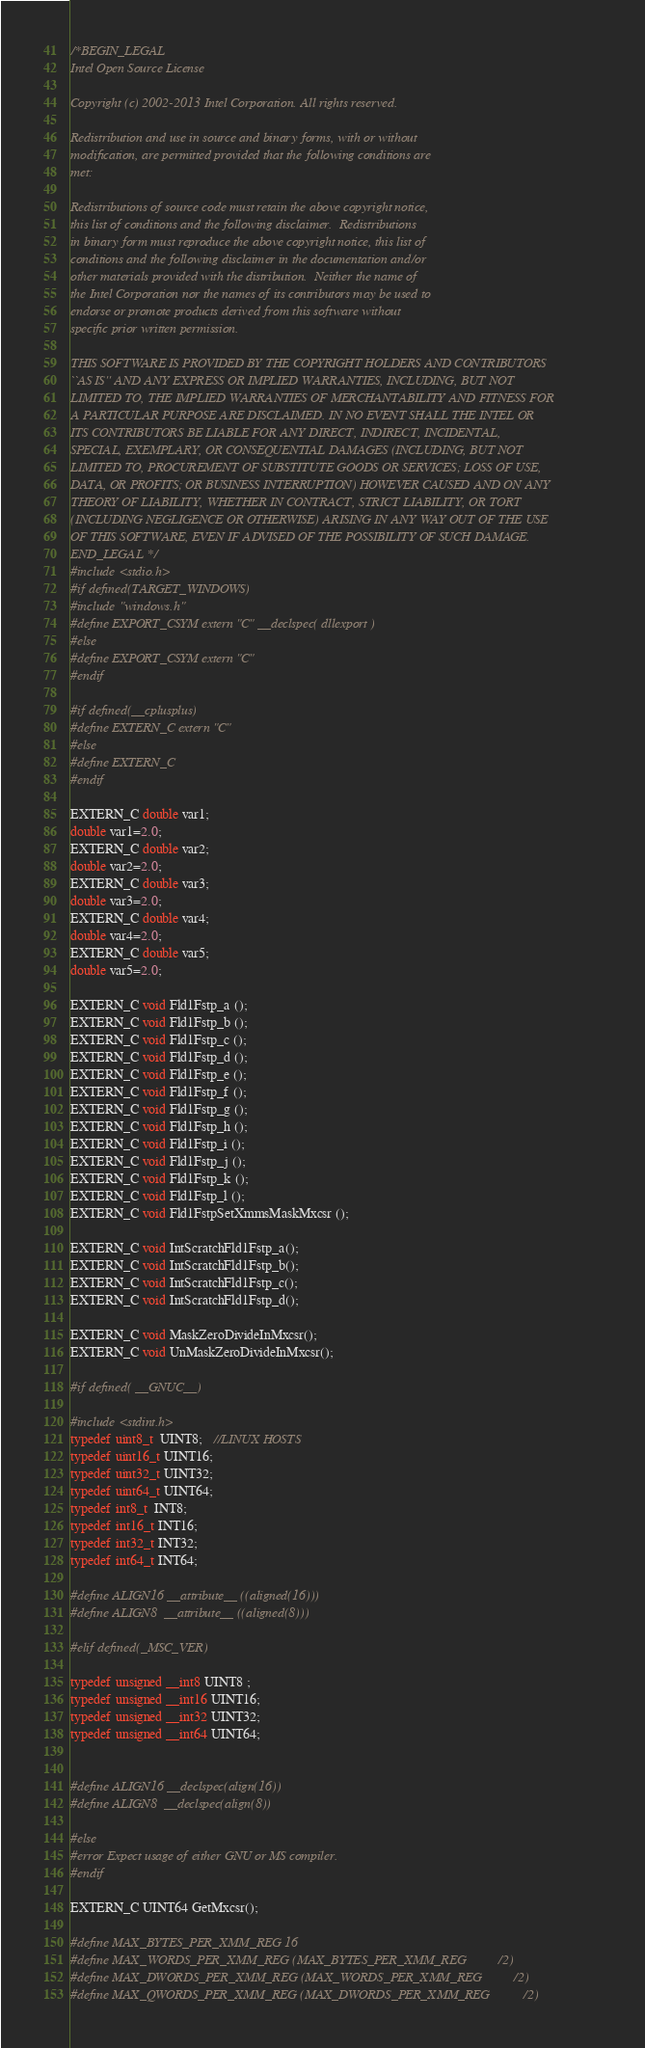<code> <loc_0><loc_0><loc_500><loc_500><_C++_>/*BEGIN_LEGAL 
Intel Open Source License 

Copyright (c) 2002-2013 Intel Corporation. All rights reserved.
 
Redistribution and use in source and binary forms, with or without
modification, are permitted provided that the following conditions are
met:

Redistributions of source code must retain the above copyright notice,
this list of conditions and the following disclaimer.  Redistributions
in binary form must reproduce the above copyright notice, this list of
conditions and the following disclaimer in the documentation and/or
other materials provided with the distribution.  Neither the name of
the Intel Corporation nor the names of its contributors may be used to
endorse or promote products derived from this software without
specific prior written permission.
 
THIS SOFTWARE IS PROVIDED BY THE COPYRIGHT HOLDERS AND CONTRIBUTORS
``AS IS'' AND ANY EXPRESS OR IMPLIED WARRANTIES, INCLUDING, BUT NOT
LIMITED TO, THE IMPLIED WARRANTIES OF MERCHANTABILITY AND FITNESS FOR
A PARTICULAR PURPOSE ARE DISCLAIMED. IN NO EVENT SHALL THE INTEL OR
ITS CONTRIBUTORS BE LIABLE FOR ANY DIRECT, INDIRECT, INCIDENTAL,
SPECIAL, EXEMPLARY, OR CONSEQUENTIAL DAMAGES (INCLUDING, BUT NOT
LIMITED TO, PROCUREMENT OF SUBSTITUTE GOODS OR SERVICES; LOSS OF USE,
DATA, OR PROFITS; OR BUSINESS INTERRUPTION) HOWEVER CAUSED AND ON ANY
THEORY OF LIABILITY, WHETHER IN CONTRACT, STRICT LIABILITY, OR TORT
(INCLUDING NEGLIGENCE OR OTHERWISE) ARISING IN ANY WAY OUT OF THE USE
OF THIS SOFTWARE, EVEN IF ADVISED OF THE POSSIBILITY OF SUCH DAMAGE.
END_LEGAL */
#include <stdio.h>
#if defined(TARGET_WINDOWS)
#include "windows.h"
#define EXPORT_CSYM extern "C" __declspec( dllexport )
#else
#define EXPORT_CSYM extern "C" 
#endif

#if defined(__cplusplus)
#define EXTERN_C extern "C"
#else
#define EXTERN_C
#endif

EXTERN_C double var1;
double var1=2.0;
EXTERN_C double var2;
double var2=2.0;
EXTERN_C double var3;
double var3=2.0;
EXTERN_C double var4;
double var4=2.0;
EXTERN_C double var5;
double var5=2.0;

EXTERN_C void Fld1Fstp_a ();
EXTERN_C void Fld1Fstp_b ();
EXTERN_C void Fld1Fstp_c ();
EXTERN_C void Fld1Fstp_d ();
EXTERN_C void Fld1Fstp_e ();
EXTERN_C void Fld1Fstp_f ();
EXTERN_C void Fld1Fstp_g ();
EXTERN_C void Fld1Fstp_h ();
EXTERN_C void Fld1Fstp_i ();
EXTERN_C void Fld1Fstp_j ();
EXTERN_C void Fld1Fstp_k ();
EXTERN_C void Fld1Fstp_l ();
EXTERN_C void Fld1FstpSetXmmsMaskMxcsr ();

EXTERN_C void IntScratchFld1Fstp_a();
EXTERN_C void IntScratchFld1Fstp_b();
EXTERN_C void IntScratchFld1Fstp_c();
EXTERN_C void IntScratchFld1Fstp_d();

EXTERN_C void MaskZeroDivideInMxcsr();
EXTERN_C void UnMaskZeroDivideInMxcsr();

#if defined( __GNUC__)

#include <stdint.h>
typedef uint8_t  UINT8;   //LINUX HOSTS
typedef uint16_t UINT16;
typedef uint32_t UINT32;
typedef uint64_t UINT64;
typedef int8_t  INT8;
typedef int16_t INT16;
typedef int32_t INT32;
typedef int64_t INT64;

#define ALIGN16 __attribute__ ((aligned(16)))
#define ALIGN8  __attribute__ ((aligned(8)))

#elif defined(_MSC_VER)

typedef unsigned __int8 UINT8 ;
typedef unsigned __int16 UINT16;
typedef unsigned __int32 UINT32;
typedef unsigned __int64 UINT64;


#define ALIGN16 __declspec(align(16))
#define ALIGN8  __declspec(align(8))

#else
#error Expect usage of either GNU or MS compiler.
#endif

EXTERN_C UINT64 GetMxcsr();

#define MAX_BYTES_PER_XMM_REG 16
#define MAX_WORDS_PER_XMM_REG (MAX_BYTES_PER_XMM_REG/2)
#define MAX_DWORDS_PER_XMM_REG (MAX_WORDS_PER_XMM_REG/2)
#define MAX_QWORDS_PER_XMM_REG (MAX_DWORDS_PER_XMM_REG/2)</code> 